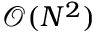Convert formula to latex. <formula><loc_0><loc_0><loc_500><loc_500>\mathcal { O } ( N ^ { 2 } )</formula> 